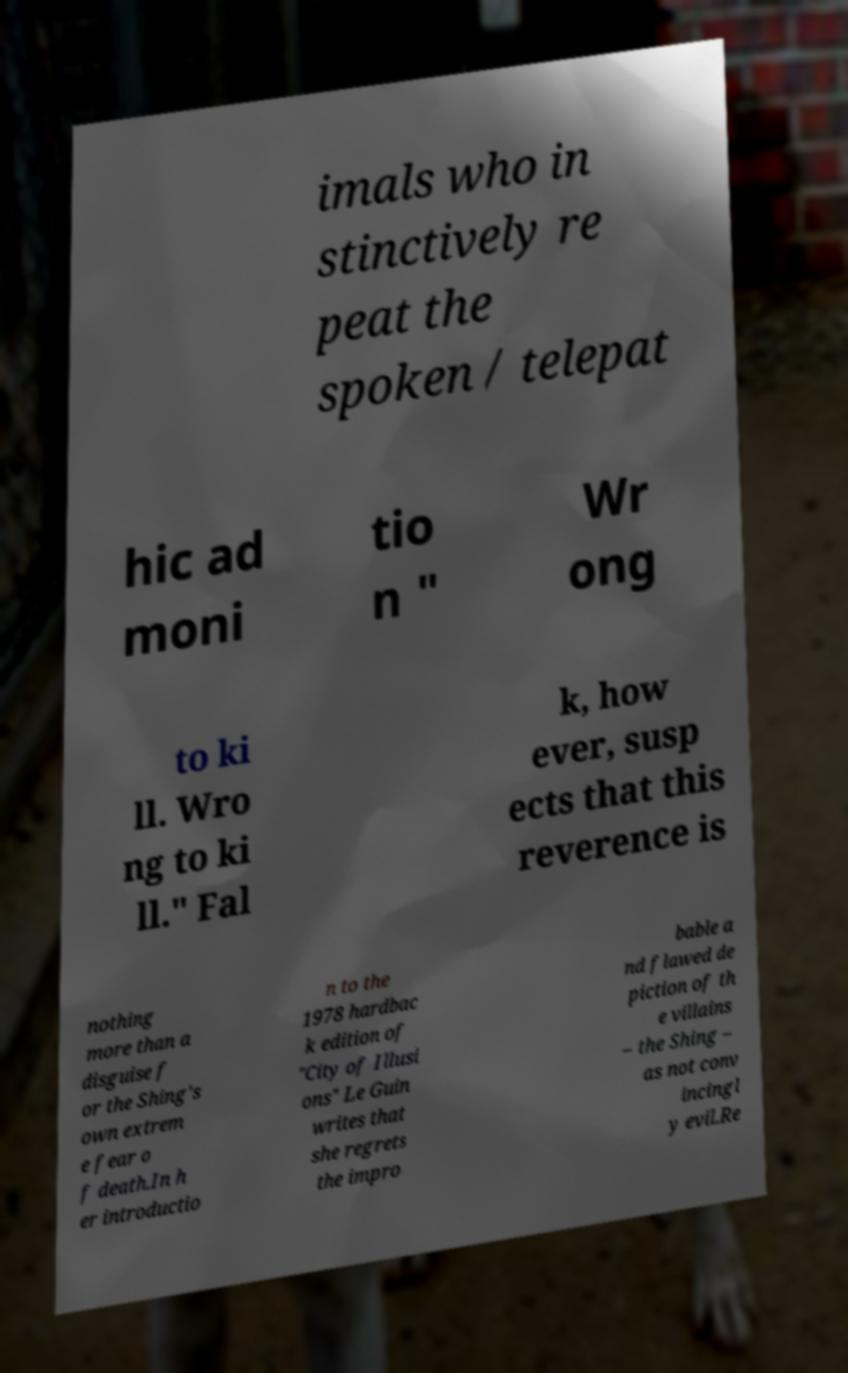There's text embedded in this image that I need extracted. Can you transcribe it verbatim? imals who in stinctively re peat the spoken / telepat hic ad moni tio n " Wr ong to ki ll. Wro ng to ki ll." Fal k, how ever, susp ects that this reverence is nothing more than a disguise f or the Shing's own extrem e fear o f death.In h er introductio n to the 1978 hardbac k edition of "City of Illusi ons" Le Guin writes that she regrets the impro bable a nd flawed de piction of th e villains – the Shing – as not conv incingl y evil.Re 